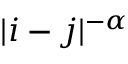<formula> <loc_0><loc_0><loc_500><loc_500>| i - j | ^ { - \alpha }</formula> 